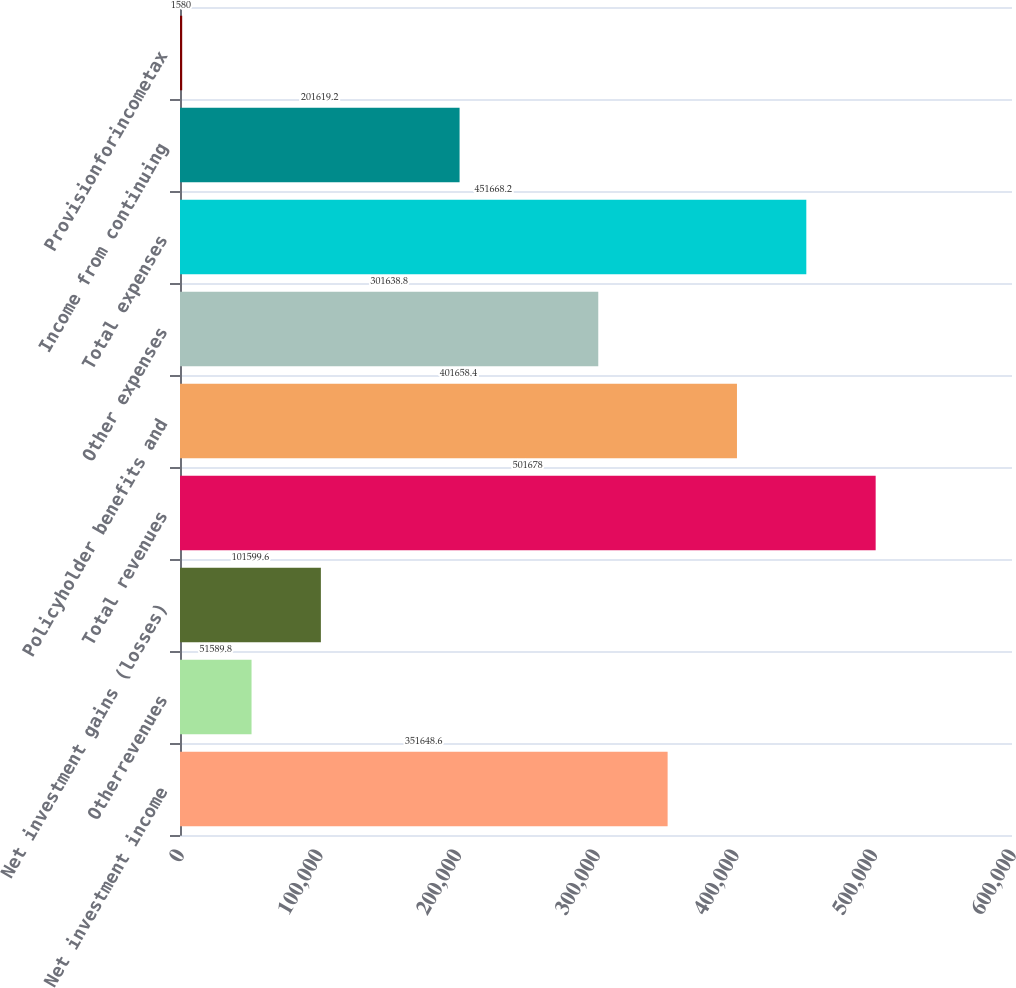<chart> <loc_0><loc_0><loc_500><loc_500><bar_chart><fcel>Net investment income<fcel>Otherrevenues<fcel>Net investment gains (losses)<fcel>Total revenues<fcel>Policyholder benefits and<fcel>Other expenses<fcel>Total expenses<fcel>Income from continuing<fcel>Provisionforincometax<nl><fcel>351649<fcel>51589.8<fcel>101600<fcel>501678<fcel>401658<fcel>301639<fcel>451668<fcel>201619<fcel>1580<nl></chart> 